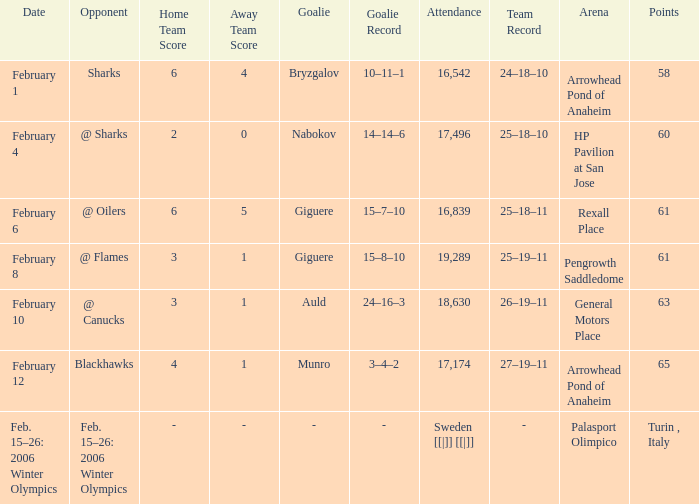What is the record when the score was 2–0? 25–18–10. 